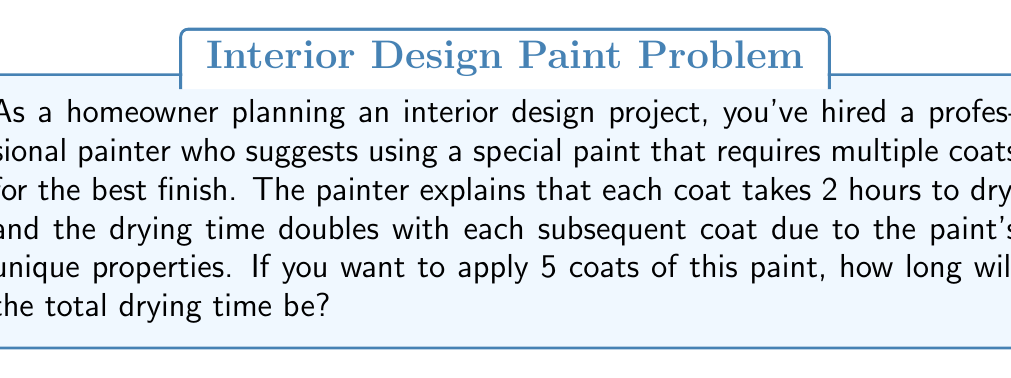Solve this math problem. Let's approach this problem step by step using exponential growth:

1) The initial drying time for the first coat is 2 hours.

2) For each subsequent coat, the drying time doubles. We can represent this as:
   $2 \cdot 2^{n-1}$, where $n$ is the coat number.

3) To find the total drying time, we need to sum the drying times for all 5 coats:

   $$\text{Total Time} = 2 + 2\cdot2^1 + 2\cdot2^2 + 2\cdot2^3 + 2\cdot2^4$$

4) Simplify:
   $$\text{Total Time} = 2 + 4 + 8 + 16 + 32$$

5) Sum up:
   $$\text{Total Time} = 62 \text{ hours}$$

This problem demonstrates exponential growth, as the drying time doubles with each coat, leading to a rapid increase in the total time required.
Answer: 62 hours 